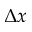<formula> <loc_0><loc_0><loc_500><loc_500>\Delta x</formula> 